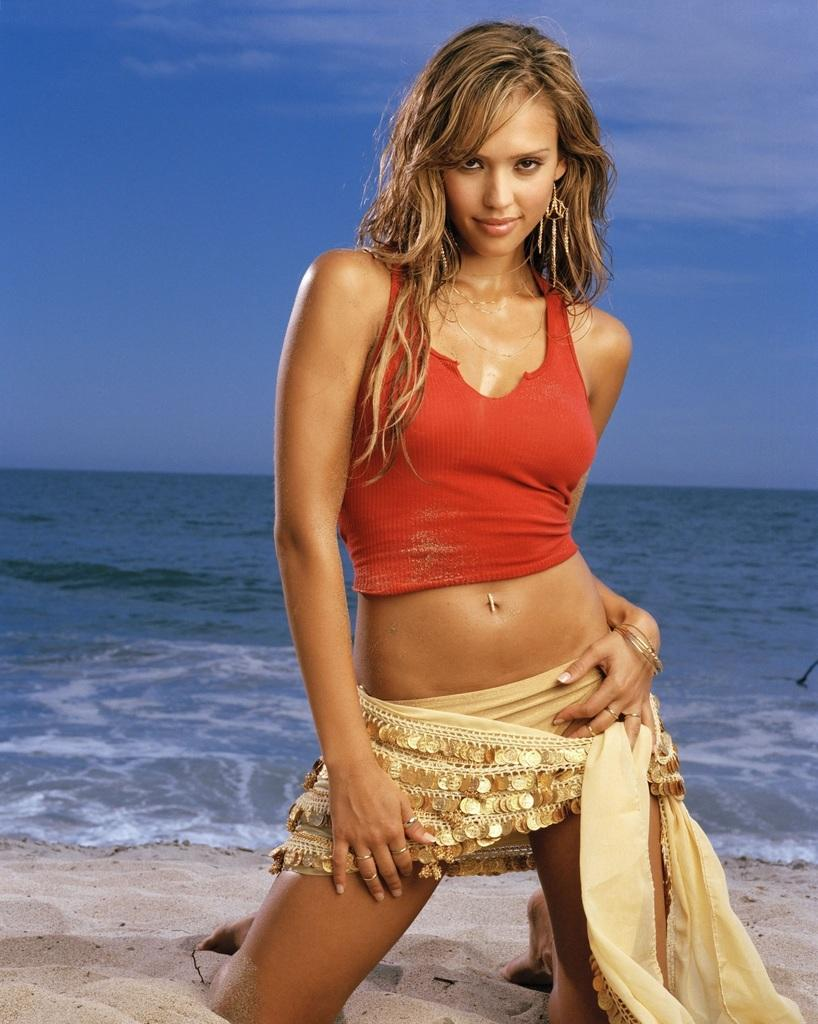Who is the main subject in the image? There is a lady in the center of the image. What type of terrain is at the bottom of the image? There is sand at the bottom of the image. What body of water is visible in the background of the image? There is a sea in the background of the image. What part of the natural environment is visible at the top of the image? The sky is visible at the top of the image. Can you see the lady's friend swimming in the sea in the image? There is no friend or swimming activity depicted in the image. 